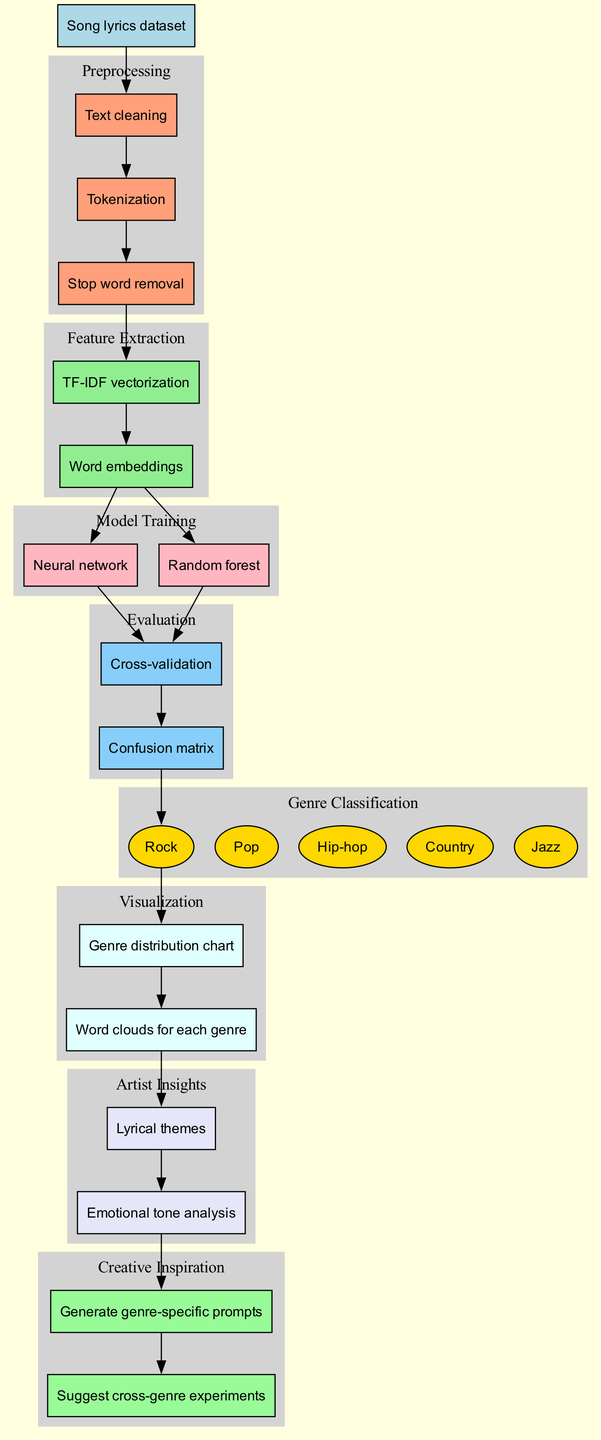What is the input data for this machine learning pipeline? The diagram indicates that the input data is a "Song lyrics dataset". This information can be found directly at the beginning of the diagram, denoting the entry point into the pipeline.
Answer: Song lyrics dataset How many preprocessing steps are in the diagram? By counting the nodes under the "Preprocessing" section, there are three steps: text cleaning, tokenization, and stop word removal. Thus, the total is three.
Answer: 3 Which models are used during model training? The diagram shows two nodes under the "Model Training" section: one is "Neural network" and the other is "Random forest". Therefore, these are the models employed in this pipeline.
Answer: Neural network, Random forest What evaluation methods are utilized in the pipeline? In the "Evaluation" section of the diagram, two methods are listed: "Cross-validation" and "Confusion matrix". These methods are used to assess the performance of the trained models.
Answer: Cross-validation, Confusion matrix Which genres are included in the genre classification? The "Genre Classification" section lists five genres: Rock, Pop, Hip-hop, Country, and Jazz. These genres are the target classifications for the model's predictions based on the lyrical content.
Answer: Rock, Pop, Hip-hop, Country, Jazz What visualizations are produced at the end of the pipeline? The diagram's "Visualization" section includes two outputs: a "Genre distribution chart" and "Word clouds for each genre". These help in visually analyzing the results of the classification.
Answer: Genre distribution chart, Word clouds for each genre What insights are gathered for the artists from this pipeline? The "Artist Insights" section reveals two insights: "Lyrical themes" and "Emotional tone analysis". These insights provide valuable information based on the lyrical content analyzed in the pipeline.
Answer: Lyrical themes, Emotional tone analysis How do the artist insights contribute to creative inspiration? The diagram connects the "Artist Insights" to the "Creative Inspiration" section, which generates "Genre-specific prompts" and suggests "Cross-genre experiments". This means that the insights directly inform and inspire creativity.
Answer: Genre-specific prompts, Cross-genre experiments What is the relationship between feature extraction and model training? The diagram illustrates that "Feature Extraction" is a prerequisite for "Model Training", as the edges indicate that the output of feature extraction feeds into the model training process.
Answer: Feature Extraction feeds into Model Training 